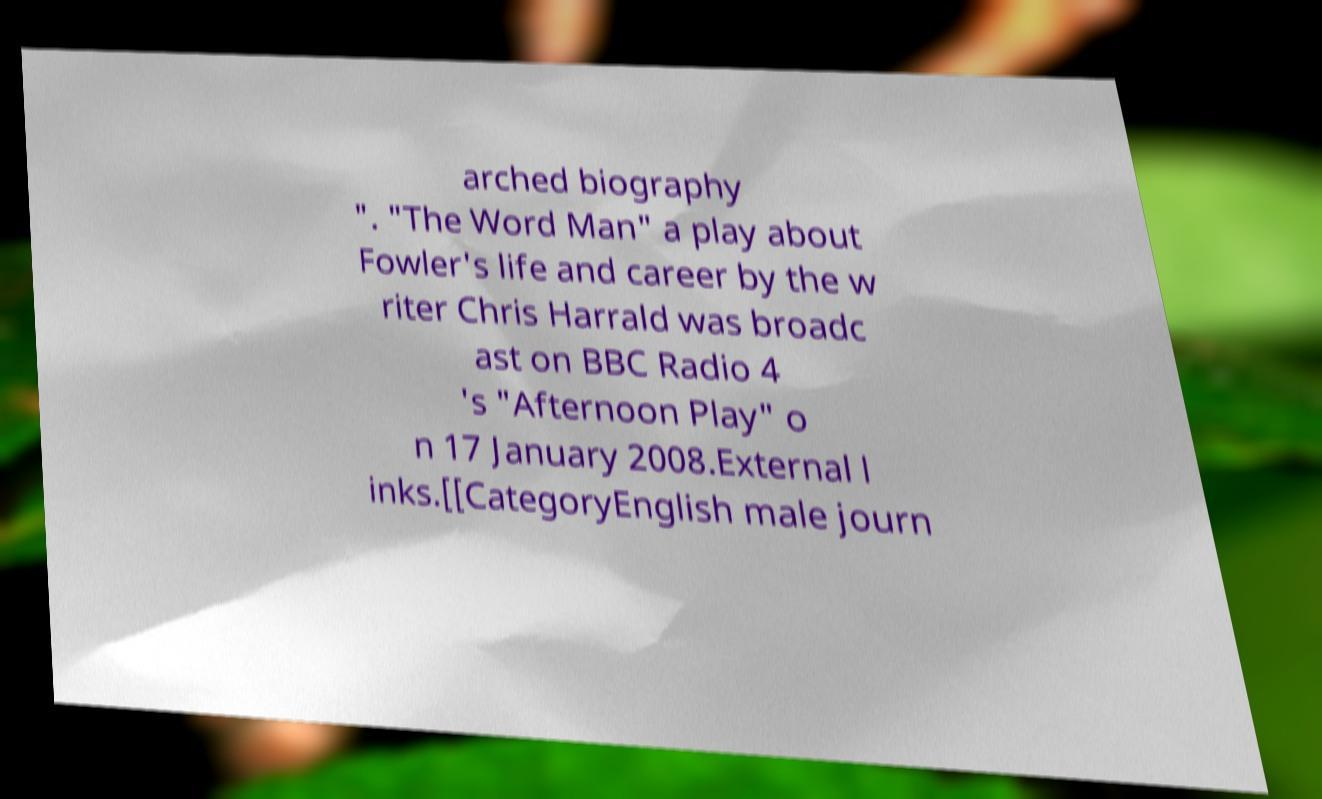I need the written content from this picture converted into text. Can you do that? arched biography ". "The Word Man" a play about Fowler's life and career by the w riter Chris Harrald was broadc ast on BBC Radio 4 's "Afternoon Play" o n 17 January 2008.External l inks.[[CategoryEnglish male journ 